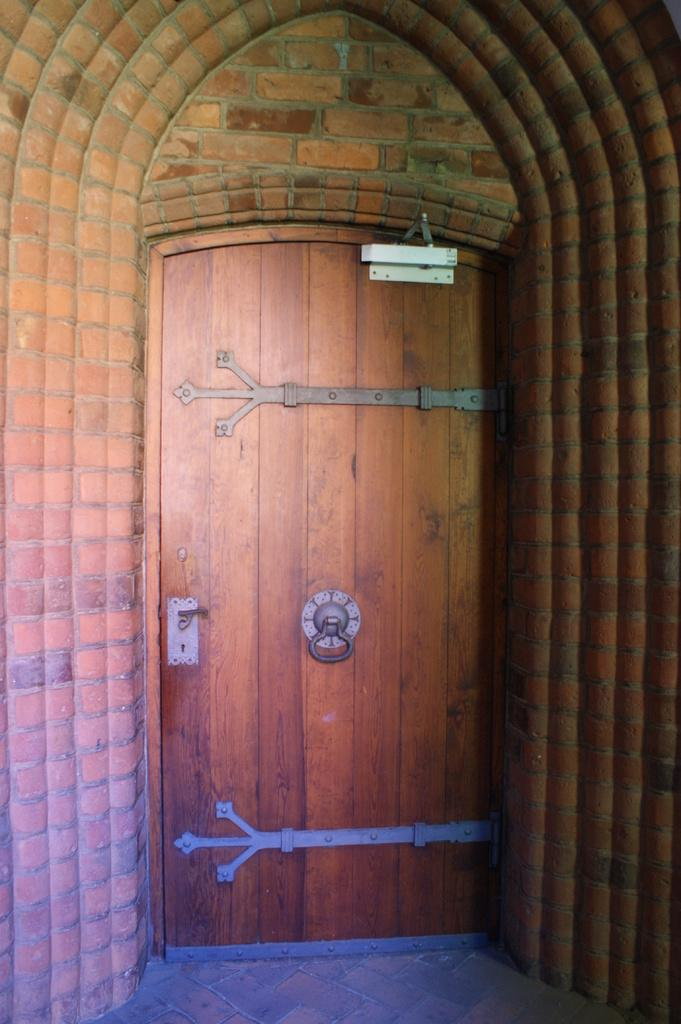What is a prominent feature in the image? There is a wall in the image. Can you describe any openings or features in the wall? There is a door in the wall. What type of jeans is the wall wearing in the image? The wall is not wearing jeans, as it is an inanimate object and does not have the ability to wear clothing. 